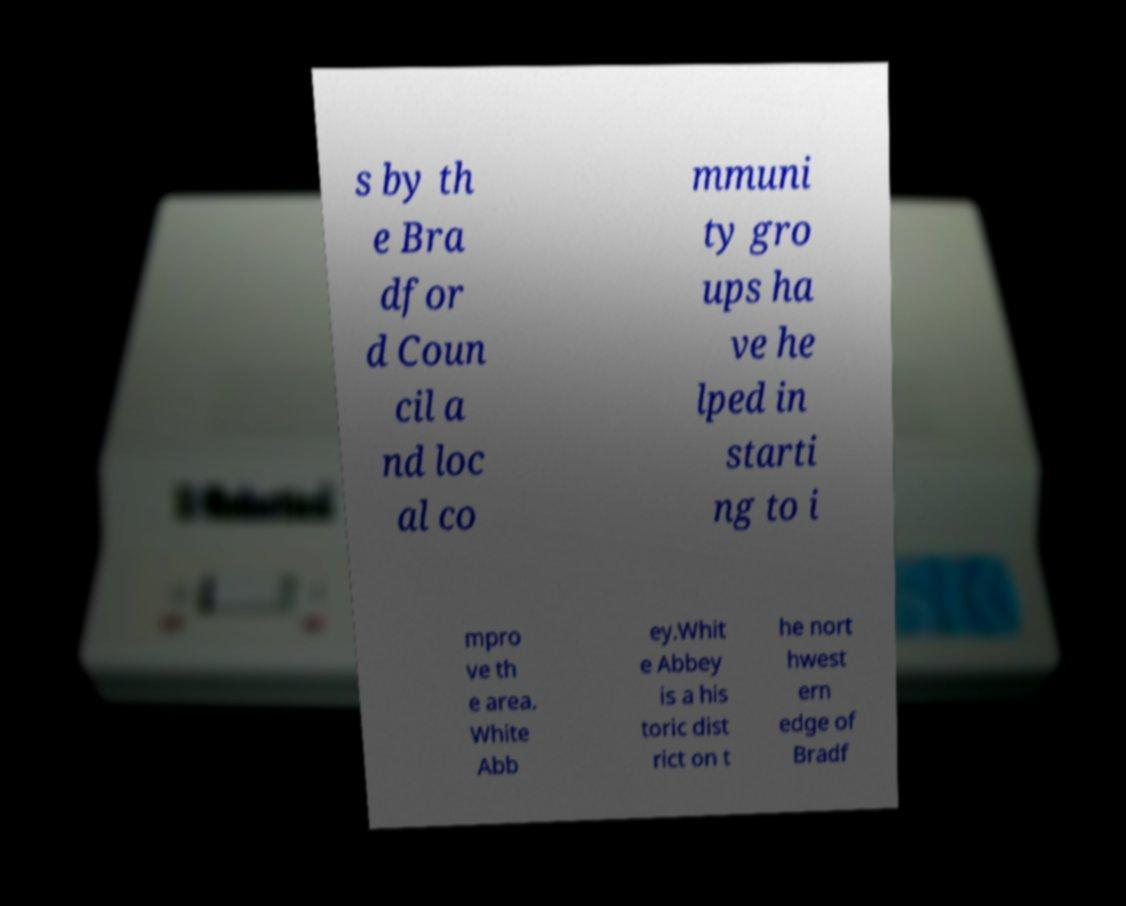I need the written content from this picture converted into text. Can you do that? s by th e Bra dfor d Coun cil a nd loc al co mmuni ty gro ups ha ve he lped in starti ng to i mpro ve th e area. White Abb ey.Whit e Abbey is a his toric dist rict on t he nort hwest ern edge of Bradf 